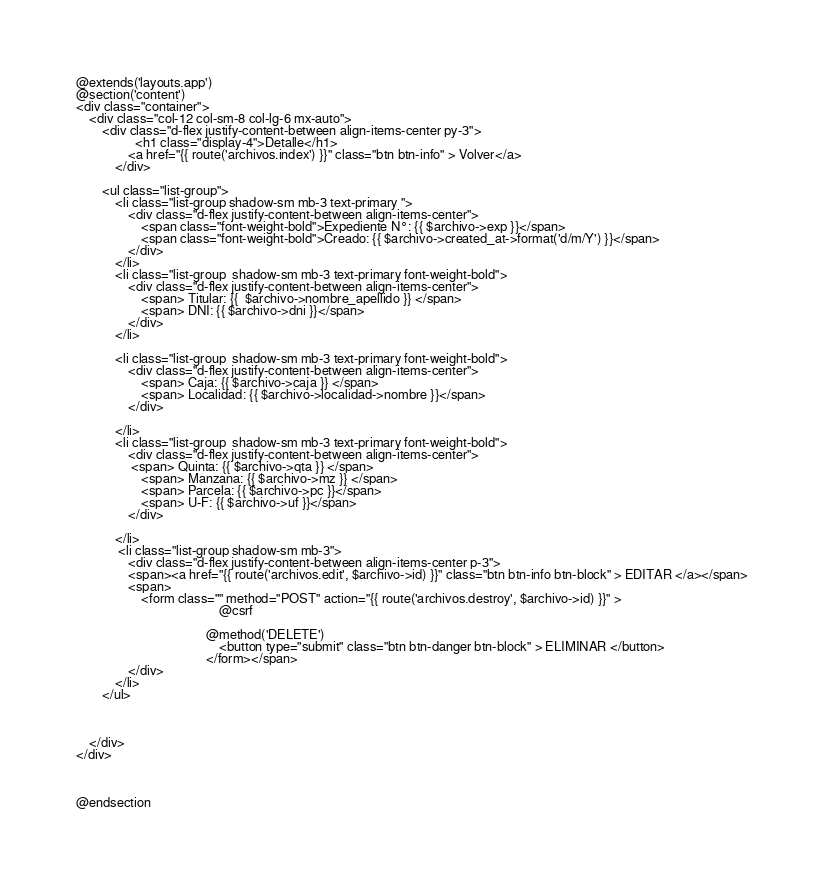<code> <loc_0><loc_0><loc_500><loc_500><_PHP_>@extends('layouts.app')
@section('content')
<div class="container">
    <div class="col-12 col-sm-8 col-lg-6 mx-auto">
        <div class="d-flex justify-content-between align-items-center py-3">
                  <h1 class="display-4">Detalle</h1>
                <a href="{{ route('archivos.index') }}" class="btn btn-info" > Volver</a>
            </div>

        <ul class="list-group">
            <li class="list-group shadow-sm mb-3 text-primary ">
                <div class="d-flex justify-content-between align-items-center">
                    <span class="font-weight-bold">Expediente N°: {{ $archivo->exp }}</span>
                    <span class="font-weight-bold">Creado: {{ $archivo->created_at->format('d/m/Y') }}</span>
                </div>
            </li>
            <li class="list-group  shadow-sm mb-3 text-primary font-weight-bold">
                <div class="d-flex justify-content-between align-items-center">
                    <span> Titular: {{  $archivo->nombre_apellido }} </span>
                    <span> DNI: {{ $archivo->dni }}</span>
                </div>
            </li>

            <li class="list-group  shadow-sm mb-3 text-primary font-weight-bold">
                <div class="d-flex justify-content-between align-items-center">
                    <span> Caja: {{ $archivo->caja }} </span>
                    <span> Localidad: {{ $archivo->localidad->nombre }}</span>
                </div>

            </li>
            <li class="list-group  shadow-sm mb-3 text-primary font-weight-bold">
                <div class="d-flex justify-content-between align-items-center">
                 <span> Quinta: {{ $archivo->qta }} </span>
                    <span> Manzana: {{ $archivo->mz }} </span>
                    <span> Parcela: {{ $archivo->pc }}</span>
                    <span> U-F: {{ $archivo->uf }}</span>
                </div>

            </li>
             <li class="list-group shadow-sm mb-3">
                <div class="d-flex justify-content-between align-items-center p-3">
                <span><a href="{{ route('archivos.edit', $archivo->id) }}" class="btn btn-info btn-block" > EDITAR </a></span>
                <span>
                    <form class="" method="POST" action="{{ route('archivos.destroy', $archivo->id) }}" >
                                            @csrf

                                        @method('DELETE')
                                            <button type="submit" class="btn btn-danger btn-block" > ELIMINAR </button>
                                        </form></span>
                </div>
            </li>
        </ul>



    </div>
</div>



@endsection
</code> 